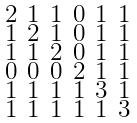Convert formula to latex. <formula><loc_0><loc_0><loc_500><loc_500>\begin{smallmatrix} 2 & 1 & 1 & 0 & 1 & 1 \\ 1 & 2 & 1 & 0 & 1 & 1 \\ 1 & 1 & 2 & 0 & 1 & 1 \\ 0 & 0 & 0 & 2 & 1 & 1 \\ 1 & 1 & 1 & 1 & 3 & 1 \\ 1 & 1 & 1 & 1 & 1 & 3 \end{smallmatrix}</formula> 